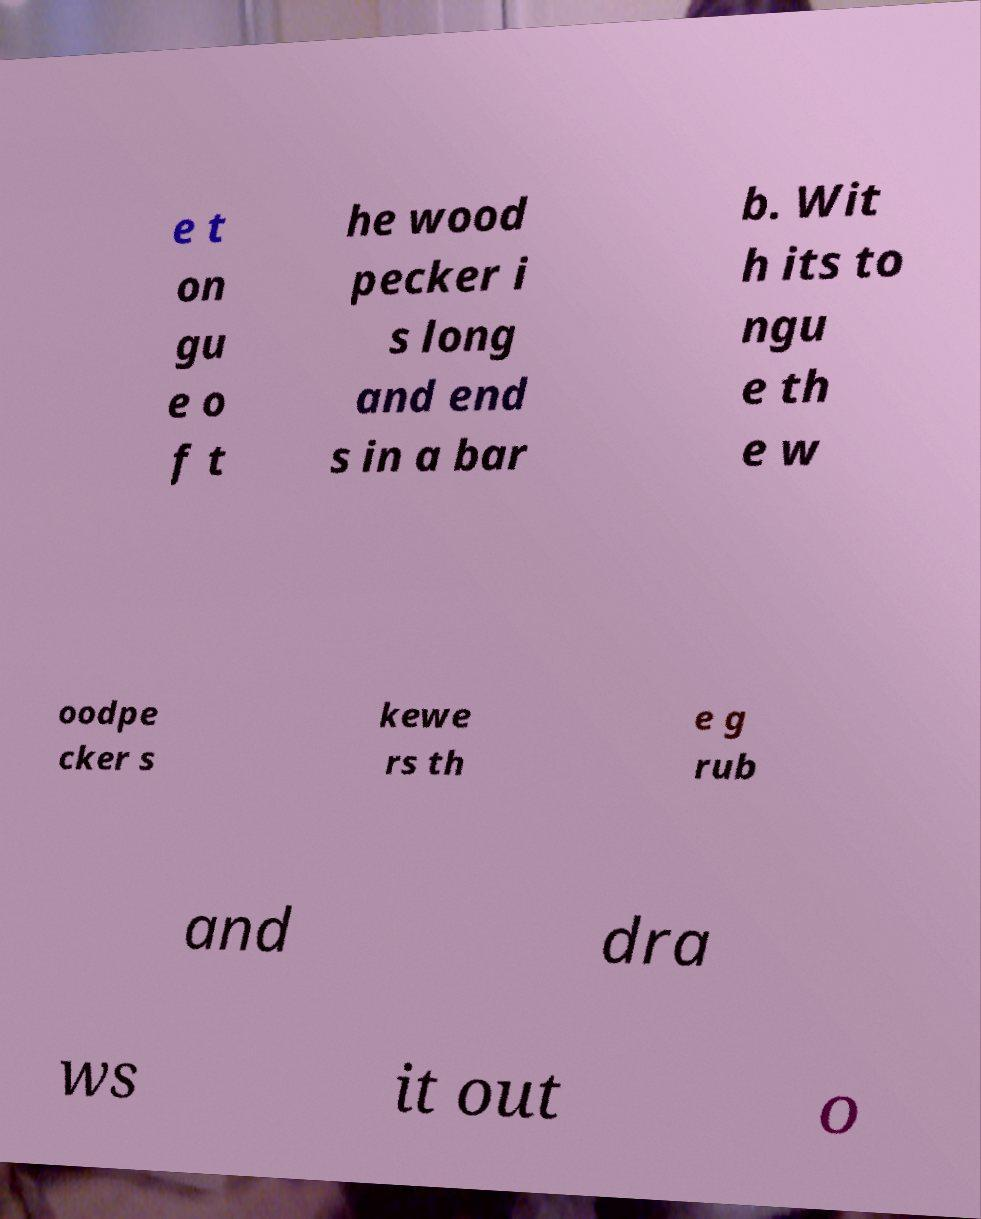Can you accurately transcribe the text from the provided image for me? e t on gu e o f t he wood pecker i s long and end s in a bar b. Wit h its to ngu e th e w oodpe cker s kewe rs th e g rub and dra ws it out o 